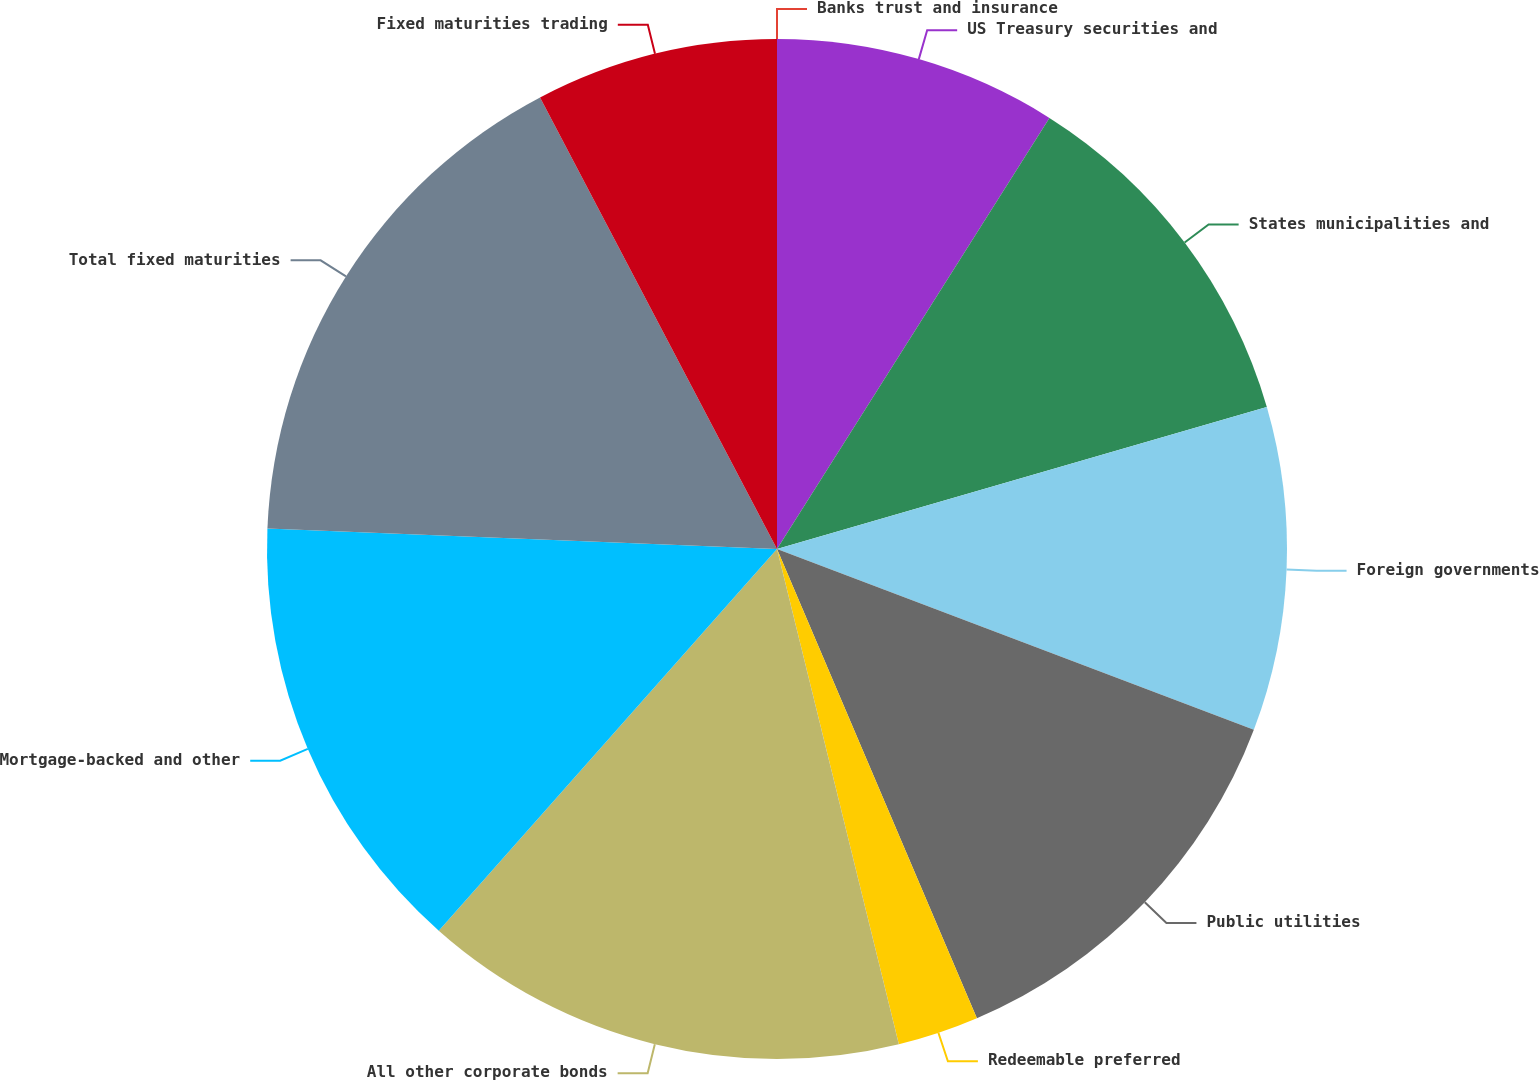<chart> <loc_0><loc_0><loc_500><loc_500><pie_chart><fcel>US Treasury securities and<fcel>States municipalities and<fcel>Foreign governments<fcel>Public utilities<fcel>Redeemable preferred<fcel>All other corporate bonds<fcel>Mortgage-backed and other<fcel>Total fixed maturities<fcel>Fixed maturities trading<fcel>Banks trust and insurance<nl><fcel>8.97%<fcel>11.54%<fcel>10.26%<fcel>12.82%<fcel>2.57%<fcel>15.38%<fcel>14.1%<fcel>16.67%<fcel>7.69%<fcel>0.0%<nl></chart> 